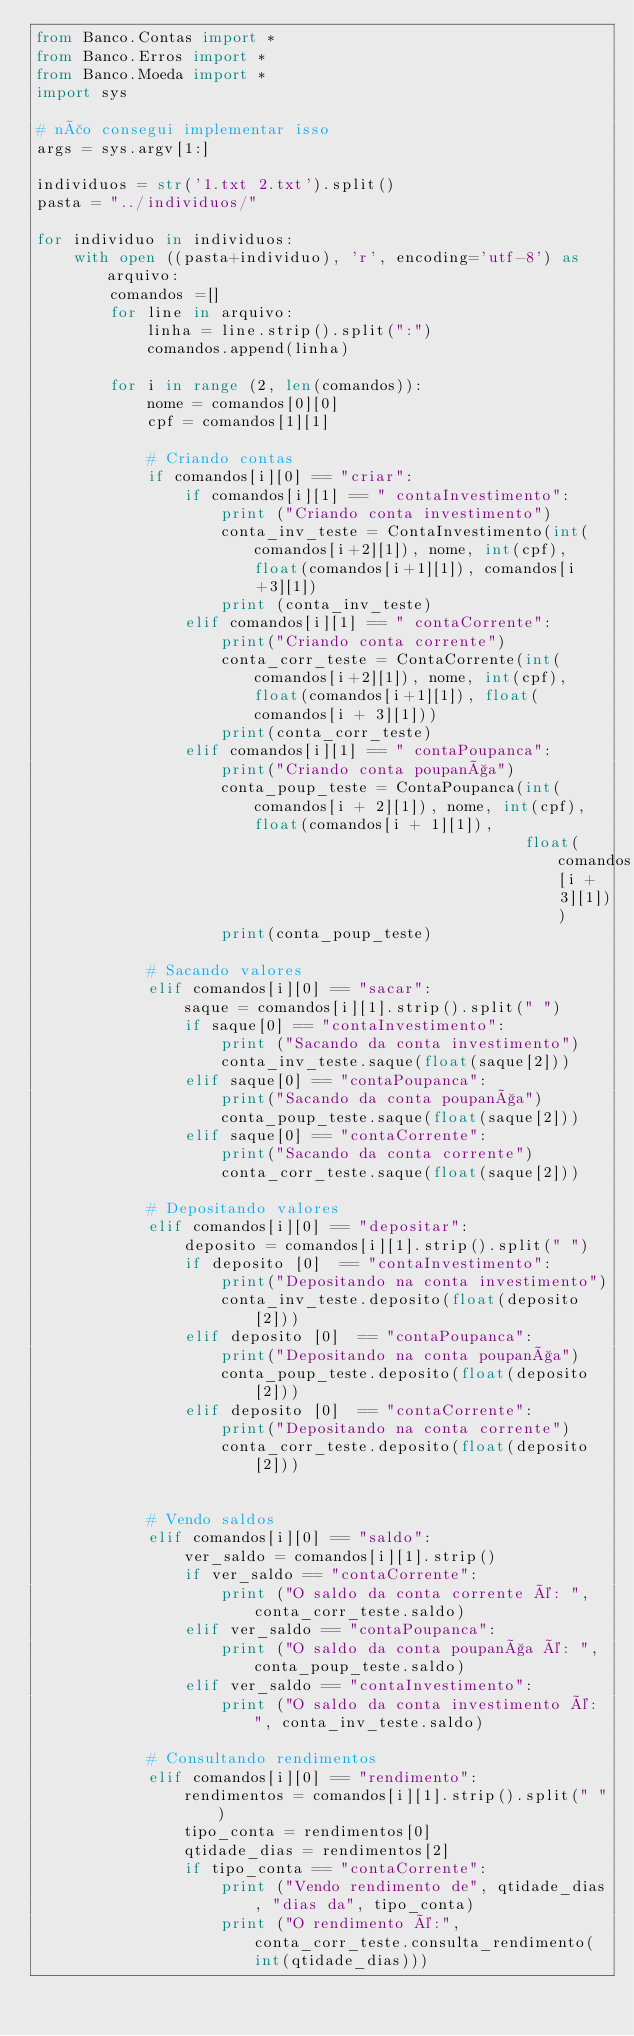Convert code to text. <code><loc_0><loc_0><loc_500><loc_500><_Python_>from Banco.Contas import *
from Banco.Erros import *
from Banco.Moeda import *
import sys

# não consegui implementar isso
args = sys.argv[1:]

individuos = str('1.txt 2.txt').split()
pasta = "../individuos/"

for individuo in individuos:
    with open ((pasta+individuo), 'r', encoding='utf-8') as arquivo:
        comandos =[]
        for line in arquivo:
            linha = line.strip().split(":")
            comandos.append(linha)

        for i in range (2, len(comandos)):
            nome = comandos[0][0]
            cpf = comandos[1][1]

            # Criando contas
            if comandos[i][0] == "criar":
                if comandos[i][1] == " contaInvestimento":
                    print ("Criando conta investimento")
                    conta_inv_teste = ContaInvestimento(int(comandos[i+2][1]), nome, int(cpf), float(comandos[i+1][1]), comandos[i+3][1])
                    print (conta_inv_teste)
                elif comandos[i][1] == " contaCorrente":
                    print("Criando conta corrente")
                    conta_corr_teste = ContaCorrente(int(comandos[i+2][1]), nome, int(cpf), float(comandos[i+1][1]), float(comandos[i + 3][1]))
                    print(conta_corr_teste)
                elif comandos[i][1] == " contaPoupanca":
                    print("Criando conta poupança")
                    conta_poup_teste = ContaPoupanca(int(comandos[i + 2][1]), nome, int(cpf), float(comandos[i + 1][1]),
                                                     float(comandos[i + 3][1]))
                    print(conta_poup_teste)

            # Sacando valores
            elif comandos[i][0] == "sacar":
                saque = comandos[i][1].strip().split(" ")
                if saque[0] == "contaInvestimento":
                    print ("Sacando da conta investimento")
                    conta_inv_teste.saque(float(saque[2]))
                elif saque[0] == "contaPoupanca":
                    print("Sacando da conta poupança")
                    conta_poup_teste.saque(float(saque[2]))
                elif saque[0] == "contaCorrente":
                    print("Sacando da conta corrente")
                    conta_corr_teste.saque(float(saque[2]))

            # Depositando valores
            elif comandos[i][0] == "depositar":
                deposito = comandos[i][1].strip().split(" ")
                if deposito [0]  == "contaInvestimento":
                    print("Depositando na conta investimento")
                    conta_inv_teste.deposito(float(deposito[2]))
                elif deposito [0]  == "contaPoupanca":
                    print("Depositando na conta poupança")
                    conta_poup_teste.deposito(float(deposito[2]))
                elif deposito [0]  == "contaCorrente":
                    print("Depositando na conta corrente")
                    conta_corr_teste.deposito(float(deposito[2]))


            # Vendo saldos
            elif comandos[i][0] == "saldo":
                ver_saldo = comandos[i][1].strip()
                if ver_saldo == "contaCorrente":
                    print ("O saldo da conta corrente é: ", conta_corr_teste.saldo)
                elif ver_saldo == "contaPoupanca":
                    print ("O saldo da conta poupança é: ", conta_poup_teste.saldo)
                elif ver_saldo == "contaInvestimento":
                    print ("O saldo da conta investimento é: ", conta_inv_teste.saldo)

            # Consultando rendimentos
            elif comandos[i][0] == "rendimento":
                rendimentos = comandos[i][1].strip().split(" ")
                tipo_conta = rendimentos[0]
                qtidade_dias = rendimentos[2]
                if tipo_conta == "contaCorrente":
                    print ("Vendo rendimento de", qtidade_dias, "dias da", tipo_conta)
                    print ("O rendimento é:", conta_corr_teste.consulta_rendimento(int(qtidade_dias)))</code> 